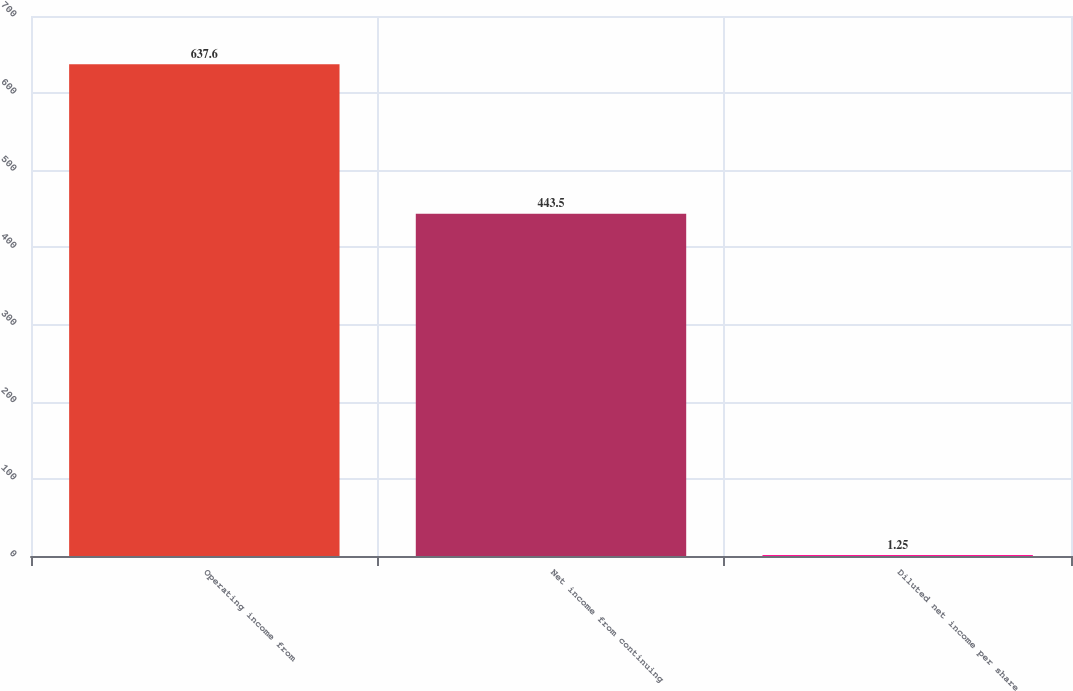<chart> <loc_0><loc_0><loc_500><loc_500><bar_chart><fcel>Operating income from<fcel>Net income from continuing<fcel>Diluted net income per share<nl><fcel>637.6<fcel>443.5<fcel>1.25<nl></chart> 